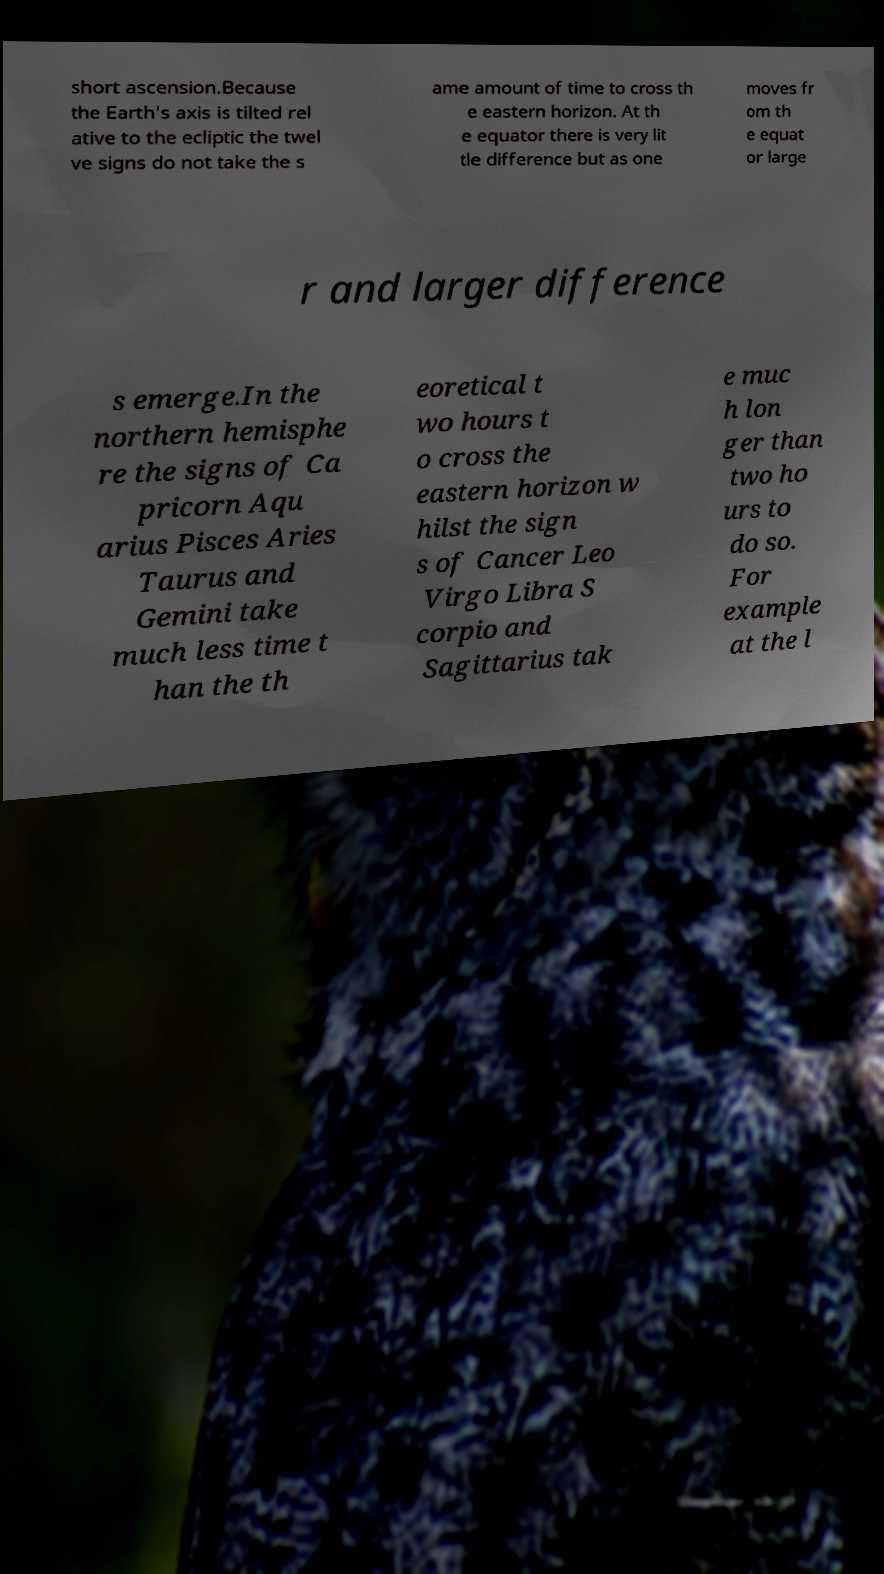There's text embedded in this image that I need extracted. Can you transcribe it verbatim? short ascension.Because the Earth's axis is tilted rel ative to the ecliptic the twel ve signs do not take the s ame amount of time to cross th e eastern horizon. At th e equator there is very lit tle difference but as one moves fr om th e equat or large r and larger difference s emerge.In the northern hemisphe re the signs of Ca pricorn Aqu arius Pisces Aries Taurus and Gemini take much less time t han the th eoretical t wo hours t o cross the eastern horizon w hilst the sign s of Cancer Leo Virgo Libra S corpio and Sagittarius tak e muc h lon ger than two ho urs to do so. For example at the l 